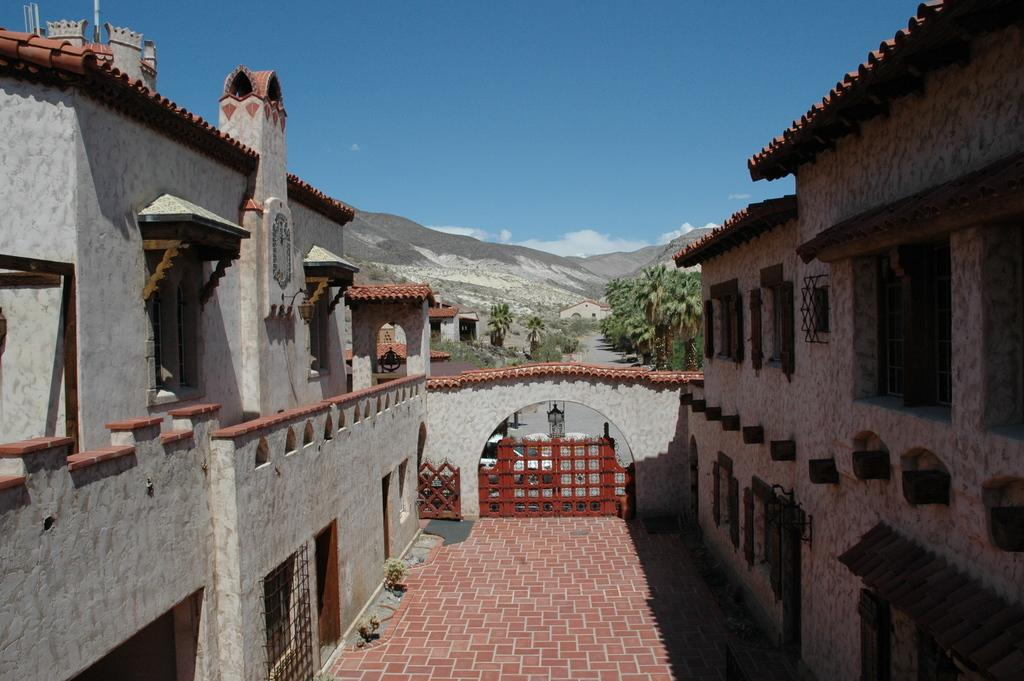What type of structures can be seen in the image? There are buildings in the image. What feature of the buildings is visible in the image? There are windows visible in the image. What type of natural elements can be seen in the image? There are trees and mountains in the image. What is the color of the sky in the image? The sky is blue and white in color. What type of plants are being used to establish a relation between the buildings in the image? There are no plants being used to establish a relation between the buildings in the image. 